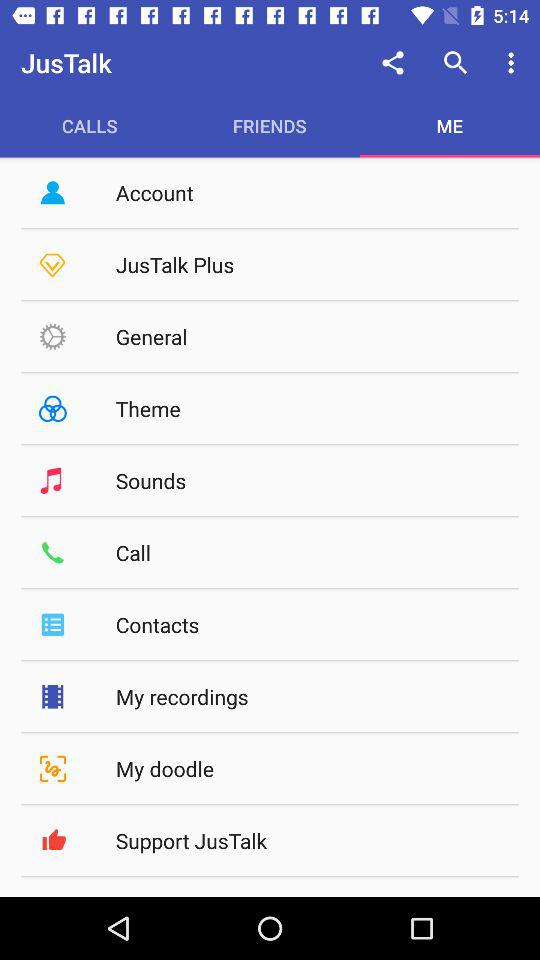Which tab is selected? The selected tab is "Me". 